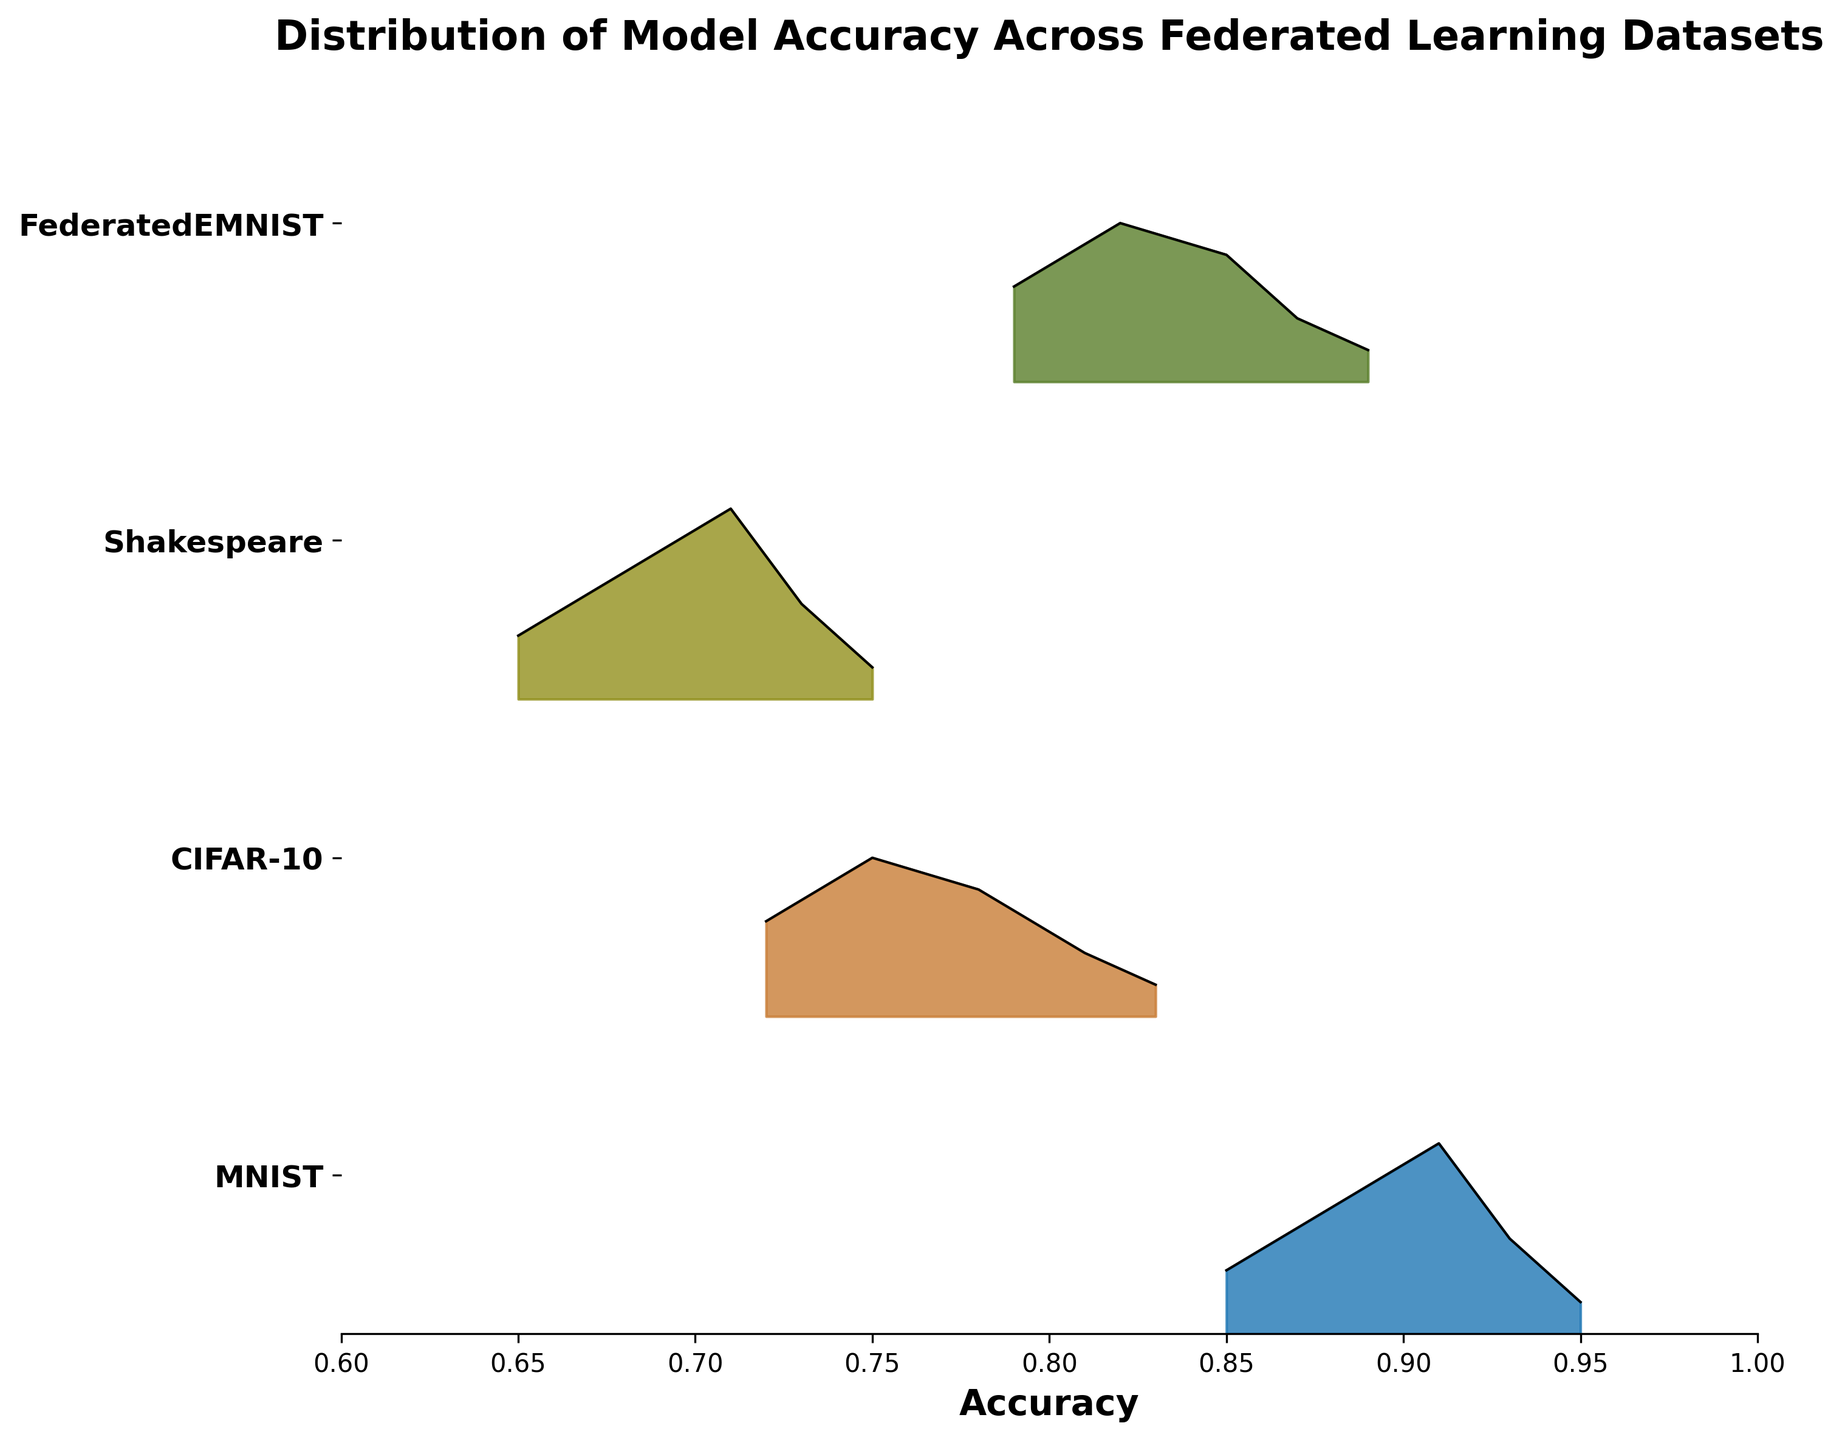What's the title of the plot? Look at the top of the plot. The title is usually displayed prominently and describes what the plot represents. The title here is: "Distribution of Model Accuracy Across Federated Learning Datasets".
Answer: Distribution of Model Accuracy Across Federated Learning Datasets What are the y-axis labels? The y-axis labels indicate the different datasets used. They should be listed along the y-axis. The labels are: MNIST, CIFAR-10, Shakespeare, FederatedEMNIST.
Answer: MNIST, CIFAR-10, Shakespeare, FederatedEMNIST Which dataset shows the highest peak in accuracy density? By examining the peaks of the ridges, look for the one that reaches the highest point on the accuracy axis. The MNIST dataset has the highest peak in the accuracy density distribution.
Answer: MNIST What is the range of accuracies shown for the FederatedEMNIST dataset? Look at the x-axis values spanned by the FederatedEMNIST ridge. The range of accuracies for FederatedEMNIST spans from 0.79 to 0.89.
Answer: 0.79 to 0.89 Which datasets have a maximum accuracy below 0.90? Review the rightmost points of each dataset's ridge and check if they are below 0.90. The datasets with maximum accuracies below 0.90 are CIFAR-10, Shakespeare, and FederatedEMNIST.
Answer: CIFAR-10, Shakespeare, FederatedEMNIST What is the approximate density value for the highest accuracy point in the Shakespeare dataset? Identify the highest accuracy in the Shakespeare dataset and look at the corresponding density value along the y-axis. The highest accuracy for Shakespeare is 0.75, and its corresponding density value is approximately 0.1.
Answer: 0.1 How does the accuracy distribution of MNIST compare to CIFAR-10? Compare the shapes and peaks of the ridges for MNIST and CIFAR-10. MNIST has a higher accuracy range and peak density, whereas CIFAR-10 shows a lower accuracy range and peak density overall.
Answer: MNIST has a higher range and peak density Among the datasets, which one has the broadest range of accuracy values? Look at the width of the ridges on the x-axis to determine which dataset spans the broadest range. MNIST has the broadest range, spanning from 0.85 to 0.95.
Answer: MNIST Which dataset has the lowest density peak in its distribution? Find the dataset whose ridge does not rise high on the y-axis, meaning it has lower density peaks throughout. FederatedEMNIST has the lowest density peak, which is around 0.1.
Answer: FederatedEMNIST 